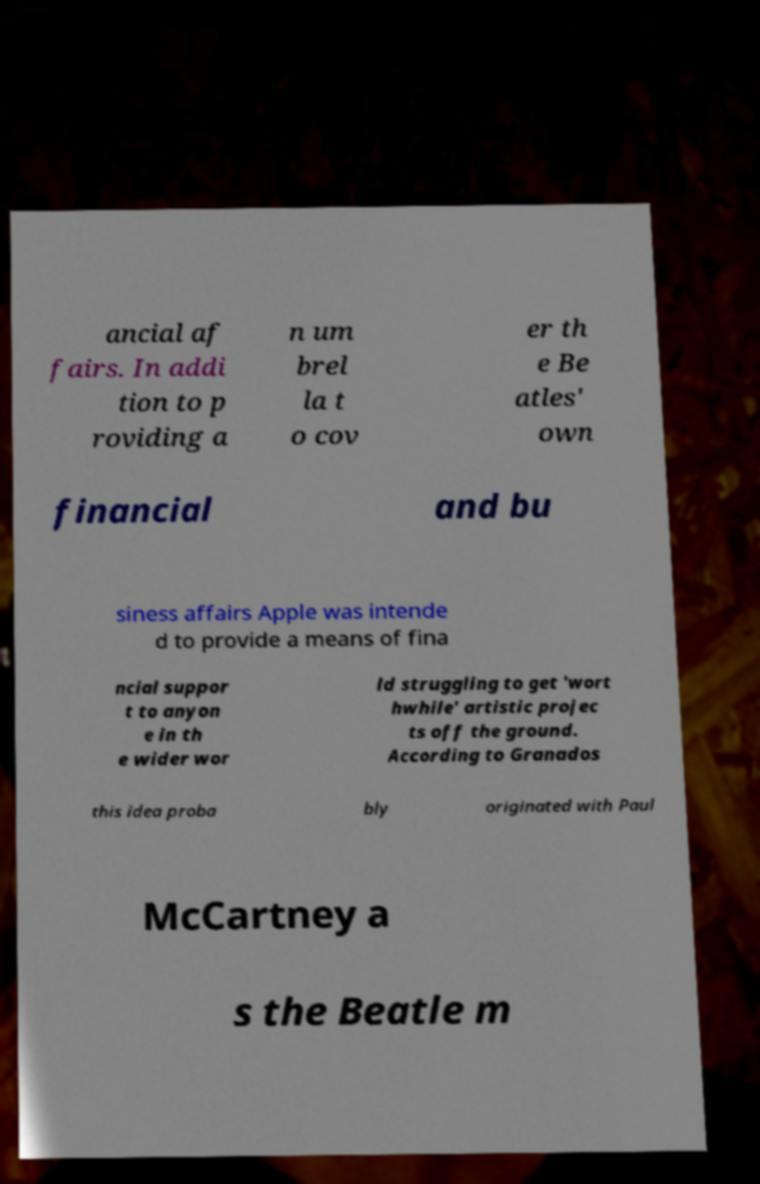There's text embedded in this image that I need extracted. Can you transcribe it verbatim? ancial af fairs. In addi tion to p roviding a n um brel la t o cov er th e Be atles' own financial and bu siness affairs Apple was intende d to provide a means of fina ncial suppor t to anyon e in th e wider wor ld struggling to get 'wort hwhile' artistic projec ts off the ground. According to Granados this idea proba bly originated with Paul McCartney a s the Beatle m 